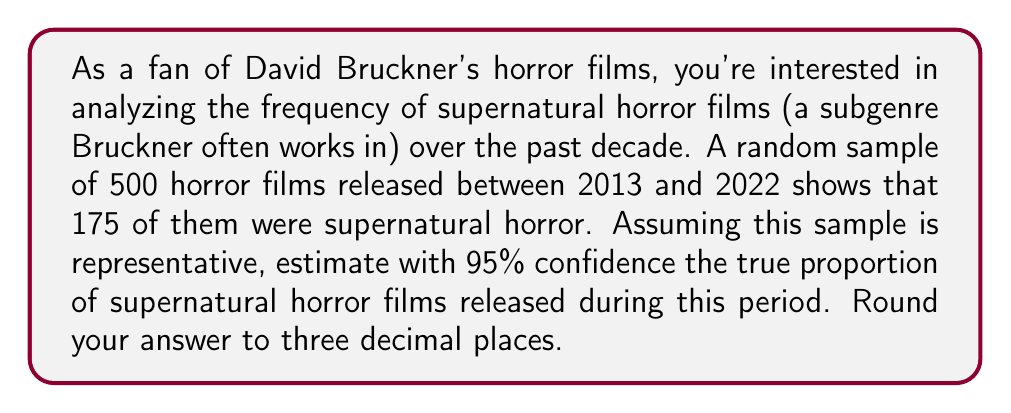Could you help me with this problem? To solve this problem, we'll use the confidence interval formula for a population proportion:

$$\hat{p} \pm z^* \sqrt{\frac{\hat{p}(1-\hat{p})}{n}}$$

Where:
$\hat{p}$ = sample proportion
$z^*$ = z-score for desired confidence level (1.96 for 95% confidence)
$n$ = sample size

Step 1: Calculate the sample proportion $\hat{p}$
$\hat{p} = \frac{175}{500} = 0.35$

Step 2: Calculate the standard error
$SE = \sqrt{\frac{\hat{p}(1-\hat{p})}{n}} = \sqrt{\frac{0.35(1-0.35)}{500}} = 0.0213$

Step 3: Calculate the margin of error
$ME = z^* \times SE = 1.96 \times 0.0213 = 0.0418$

Step 4: Calculate the confidence interval
Lower bound: $0.35 - 0.0418 = 0.3082$
Upper bound: $0.35 + 0.0418 = 0.3918$

Therefore, we can estimate with 95% confidence that the true proportion of supernatural horror films released between 2013 and 2022 is between 0.308 and 0.392, or 30.8% to 39.2%.
Answer: The 95% confidence interval for the true proportion of supernatural horror films is (0.308, 0.392). 